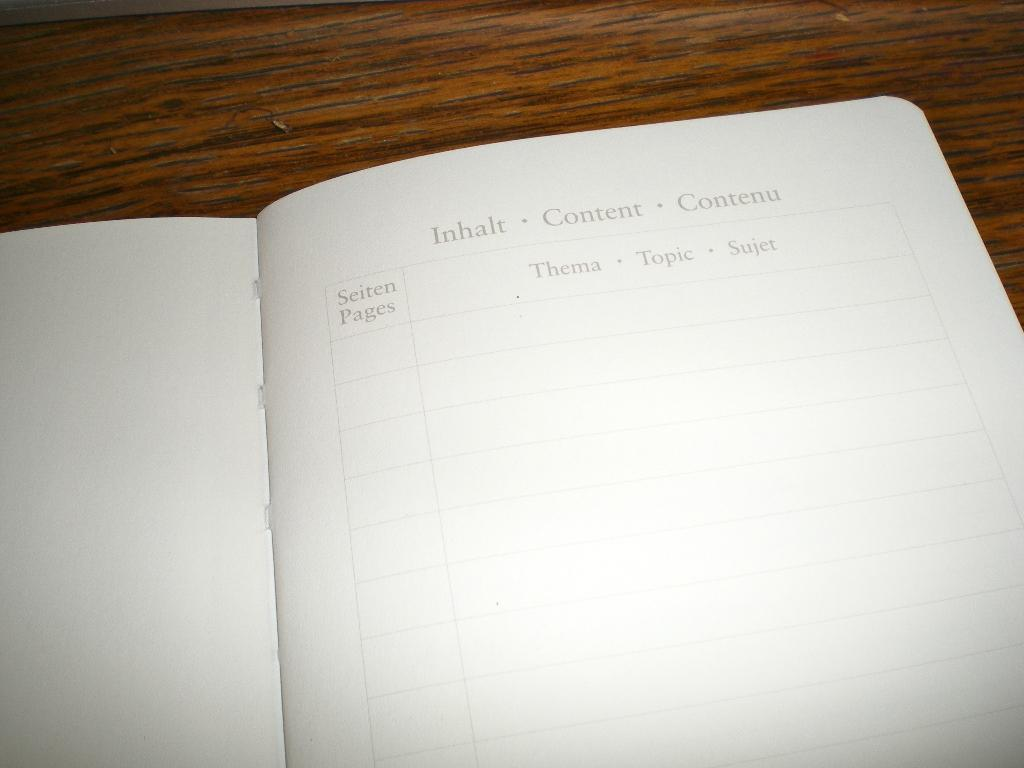<image>
Offer a succinct explanation of the picture presented. An open notebook with Inhalt Content Contenu as the heading 